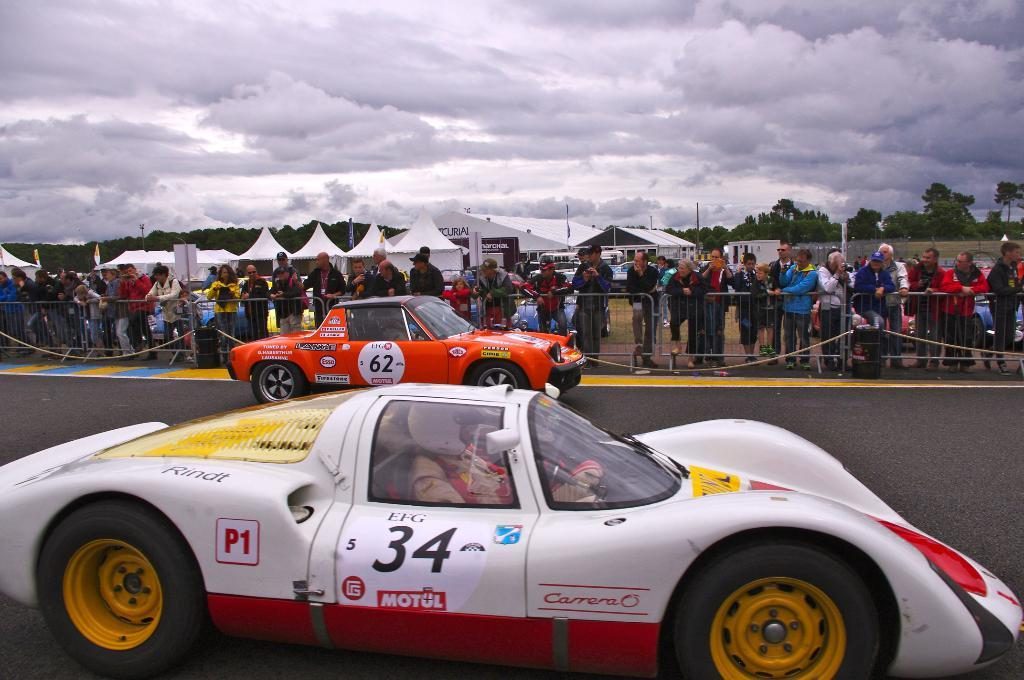How many vehicles are on the road in the image? There are two vehicles on the road in the image. What can be seen in the background of the image? In the background, there is a fence, persons standing, white color tents, trees, and clouds in the sky. What color is the airport in the image? There is no airport present in the image. 